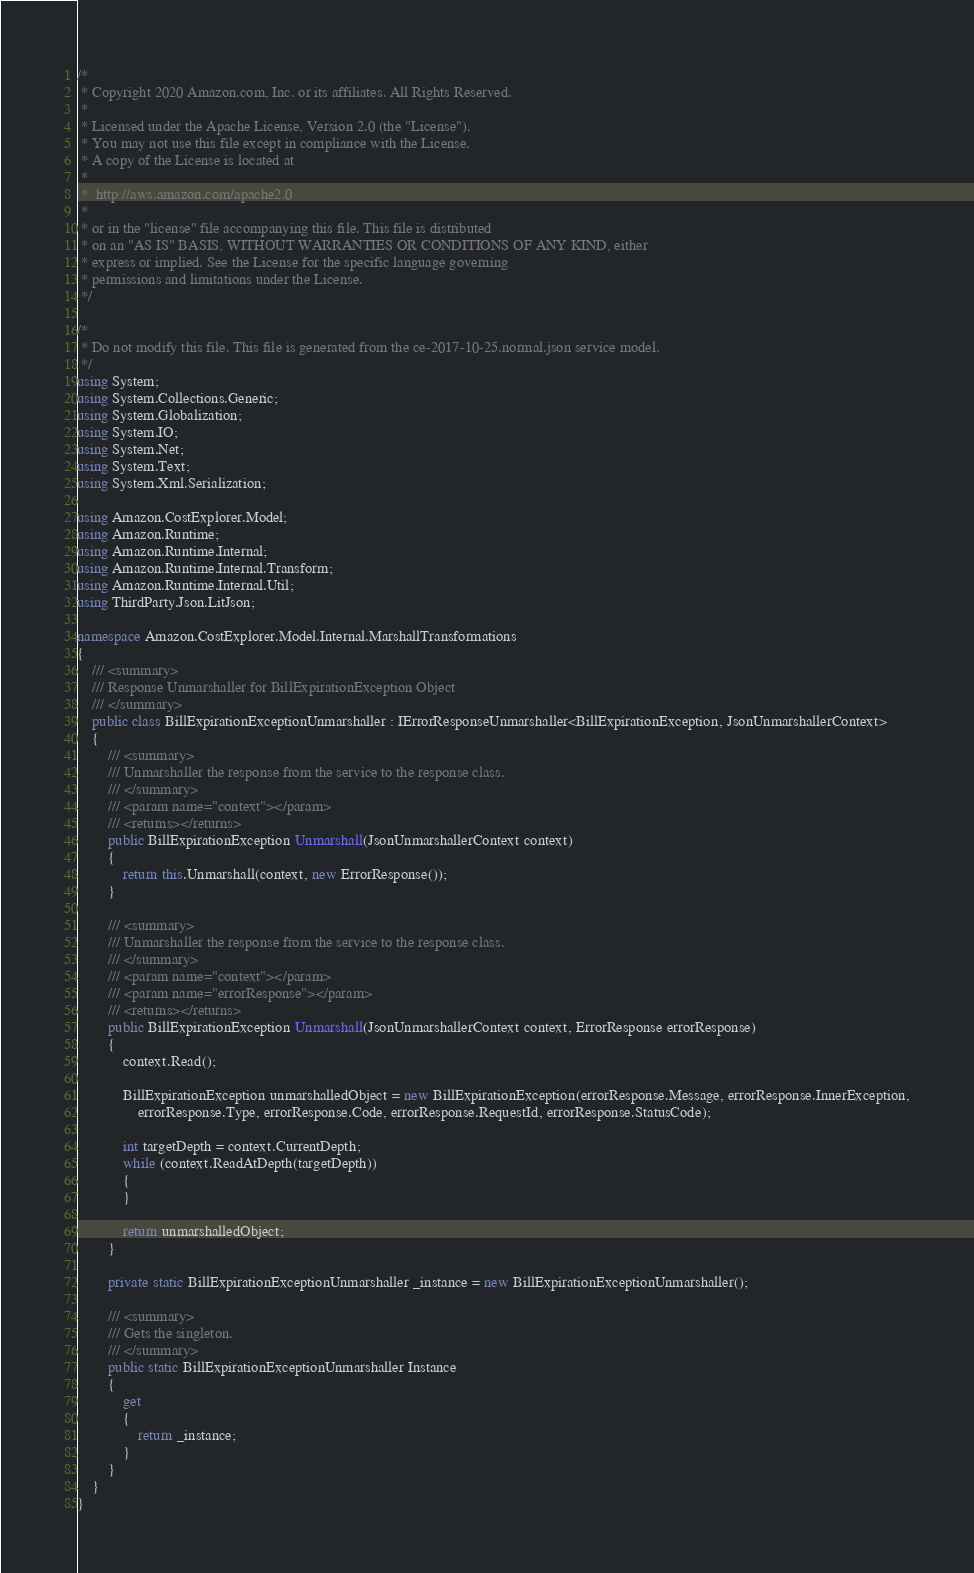Convert code to text. <code><loc_0><loc_0><loc_500><loc_500><_C#_>/*
 * Copyright 2020 Amazon.com, Inc. or its affiliates. All Rights Reserved.
 * 
 * Licensed under the Apache License, Version 2.0 (the "License").
 * You may not use this file except in compliance with the License.
 * A copy of the License is located at
 * 
 *  http://aws.amazon.com/apache2.0
 * 
 * or in the "license" file accompanying this file. This file is distributed
 * on an "AS IS" BASIS, WITHOUT WARRANTIES OR CONDITIONS OF ANY KIND, either
 * express or implied. See the License for the specific language governing
 * permissions and limitations under the License.
 */

/*
 * Do not modify this file. This file is generated from the ce-2017-10-25.normal.json service model.
 */
using System;
using System.Collections.Generic;
using System.Globalization;
using System.IO;
using System.Net;
using System.Text;
using System.Xml.Serialization;

using Amazon.CostExplorer.Model;
using Amazon.Runtime;
using Amazon.Runtime.Internal;
using Amazon.Runtime.Internal.Transform;
using Amazon.Runtime.Internal.Util;
using ThirdParty.Json.LitJson;

namespace Amazon.CostExplorer.Model.Internal.MarshallTransformations
{
    /// <summary>
    /// Response Unmarshaller for BillExpirationException Object
    /// </summary>  
    public class BillExpirationExceptionUnmarshaller : IErrorResponseUnmarshaller<BillExpirationException, JsonUnmarshallerContext>
    {
        /// <summary>
        /// Unmarshaller the response from the service to the response class.
        /// </summary>  
        /// <param name="context"></param>
        /// <returns></returns>
        public BillExpirationException Unmarshall(JsonUnmarshallerContext context)
        {
            return this.Unmarshall(context, new ErrorResponse());
        }

        /// <summary>
        /// Unmarshaller the response from the service to the response class.
        /// </summary>  
        /// <param name="context"></param>
        /// <param name="errorResponse"></param>
        /// <returns></returns>
        public BillExpirationException Unmarshall(JsonUnmarshallerContext context, ErrorResponse errorResponse)
        {
            context.Read();

            BillExpirationException unmarshalledObject = new BillExpirationException(errorResponse.Message, errorResponse.InnerException,
                errorResponse.Type, errorResponse.Code, errorResponse.RequestId, errorResponse.StatusCode);
        
            int targetDepth = context.CurrentDepth;
            while (context.ReadAtDepth(targetDepth))
            {
            }
          
            return unmarshalledObject;
        }

        private static BillExpirationExceptionUnmarshaller _instance = new BillExpirationExceptionUnmarshaller();        

        /// <summary>
        /// Gets the singleton.
        /// </summary>  
        public static BillExpirationExceptionUnmarshaller Instance
        {
            get
            {
                return _instance;
            }
        }
    }
}</code> 